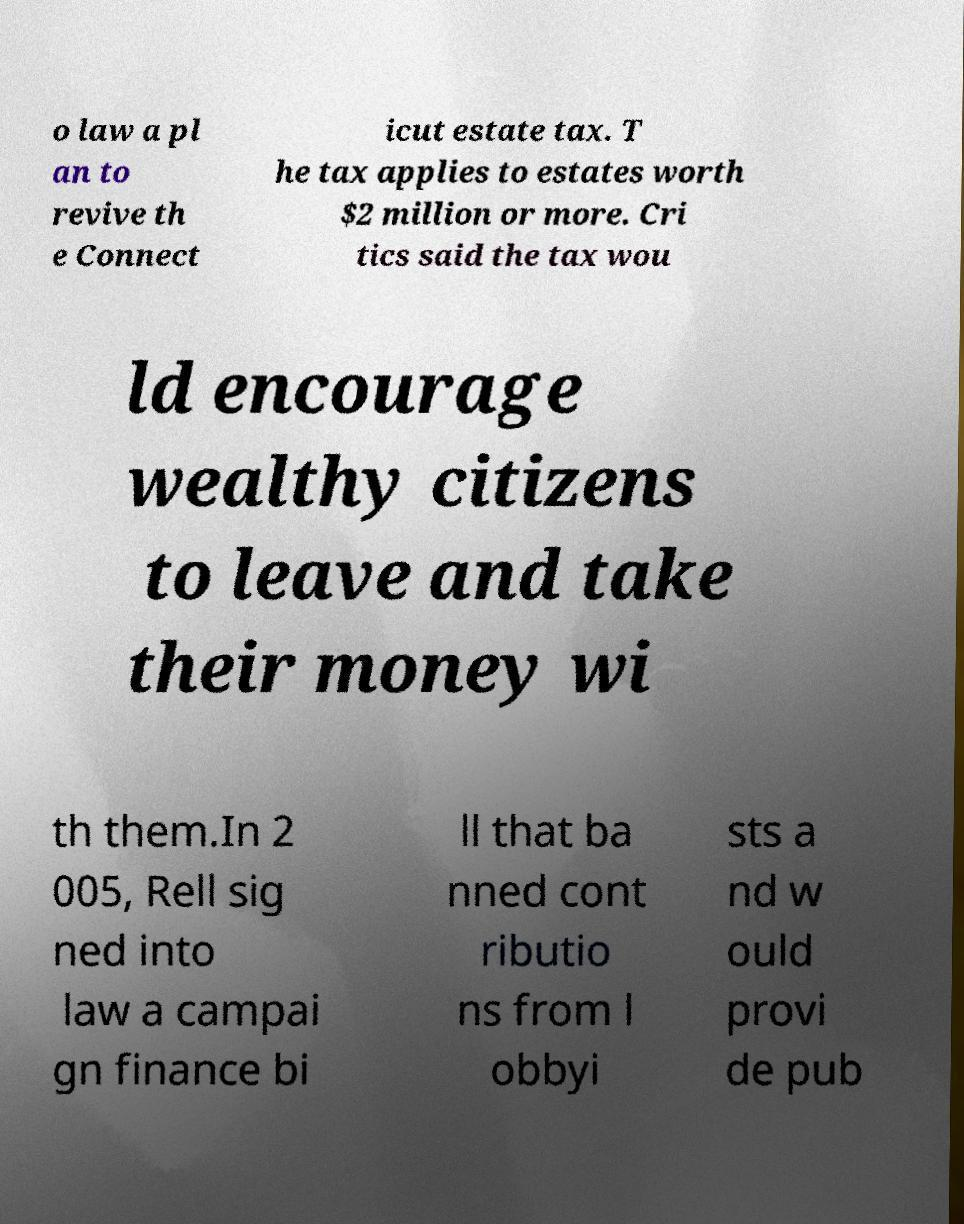Please read and relay the text visible in this image. What does it say? o law a pl an to revive th e Connect icut estate tax. T he tax applies to estates worth $2 million or more. Cri tics said the tax wou ld encourage wealthy citizens to leave and take their money wi th them.In 2 005, Rell sig ned into law a campai gn finance bi ll that ba nned cont ributio ns from l obbyi sts a nd w ould provi de pub 